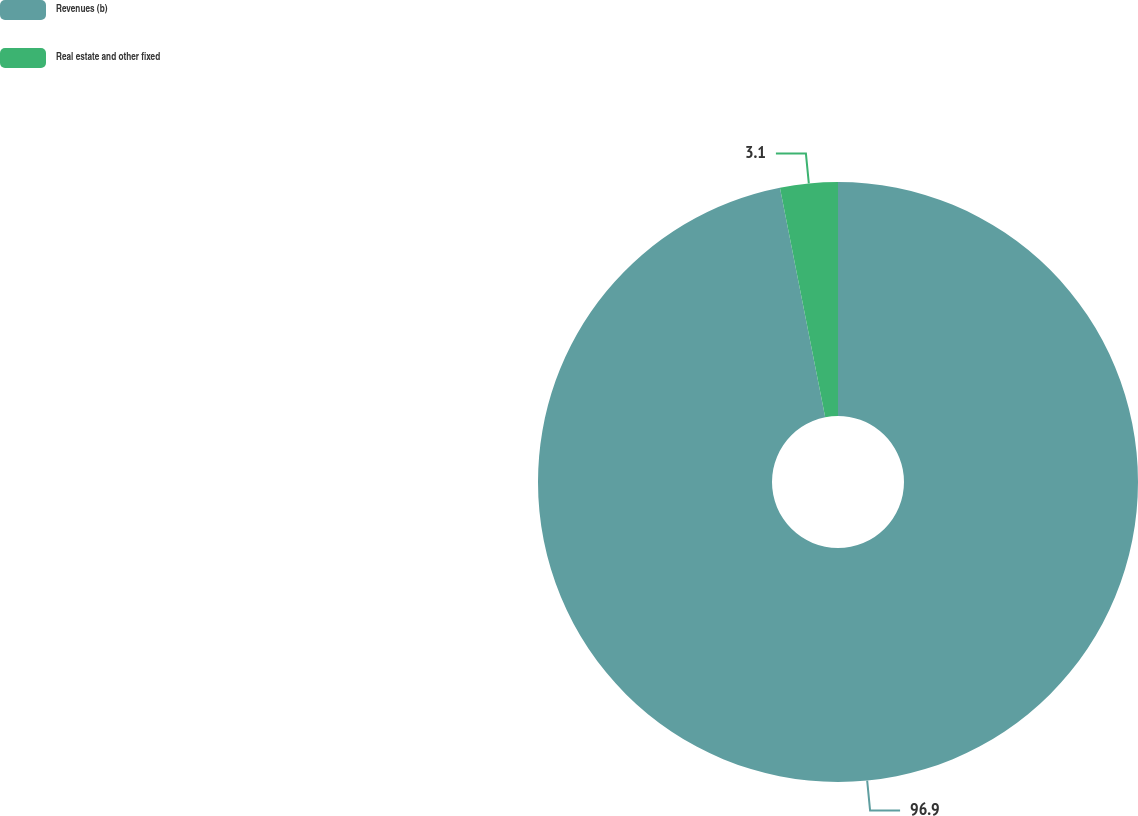Convert chart to OTSL. <chart><loc_0><loc_0><loc_500><loc_500><pie_chart><fcel>Revenues (b)<fcel>Real estate and other fixed<nl><fcel>96.9%<fcel>3.1%<nl></chart> 